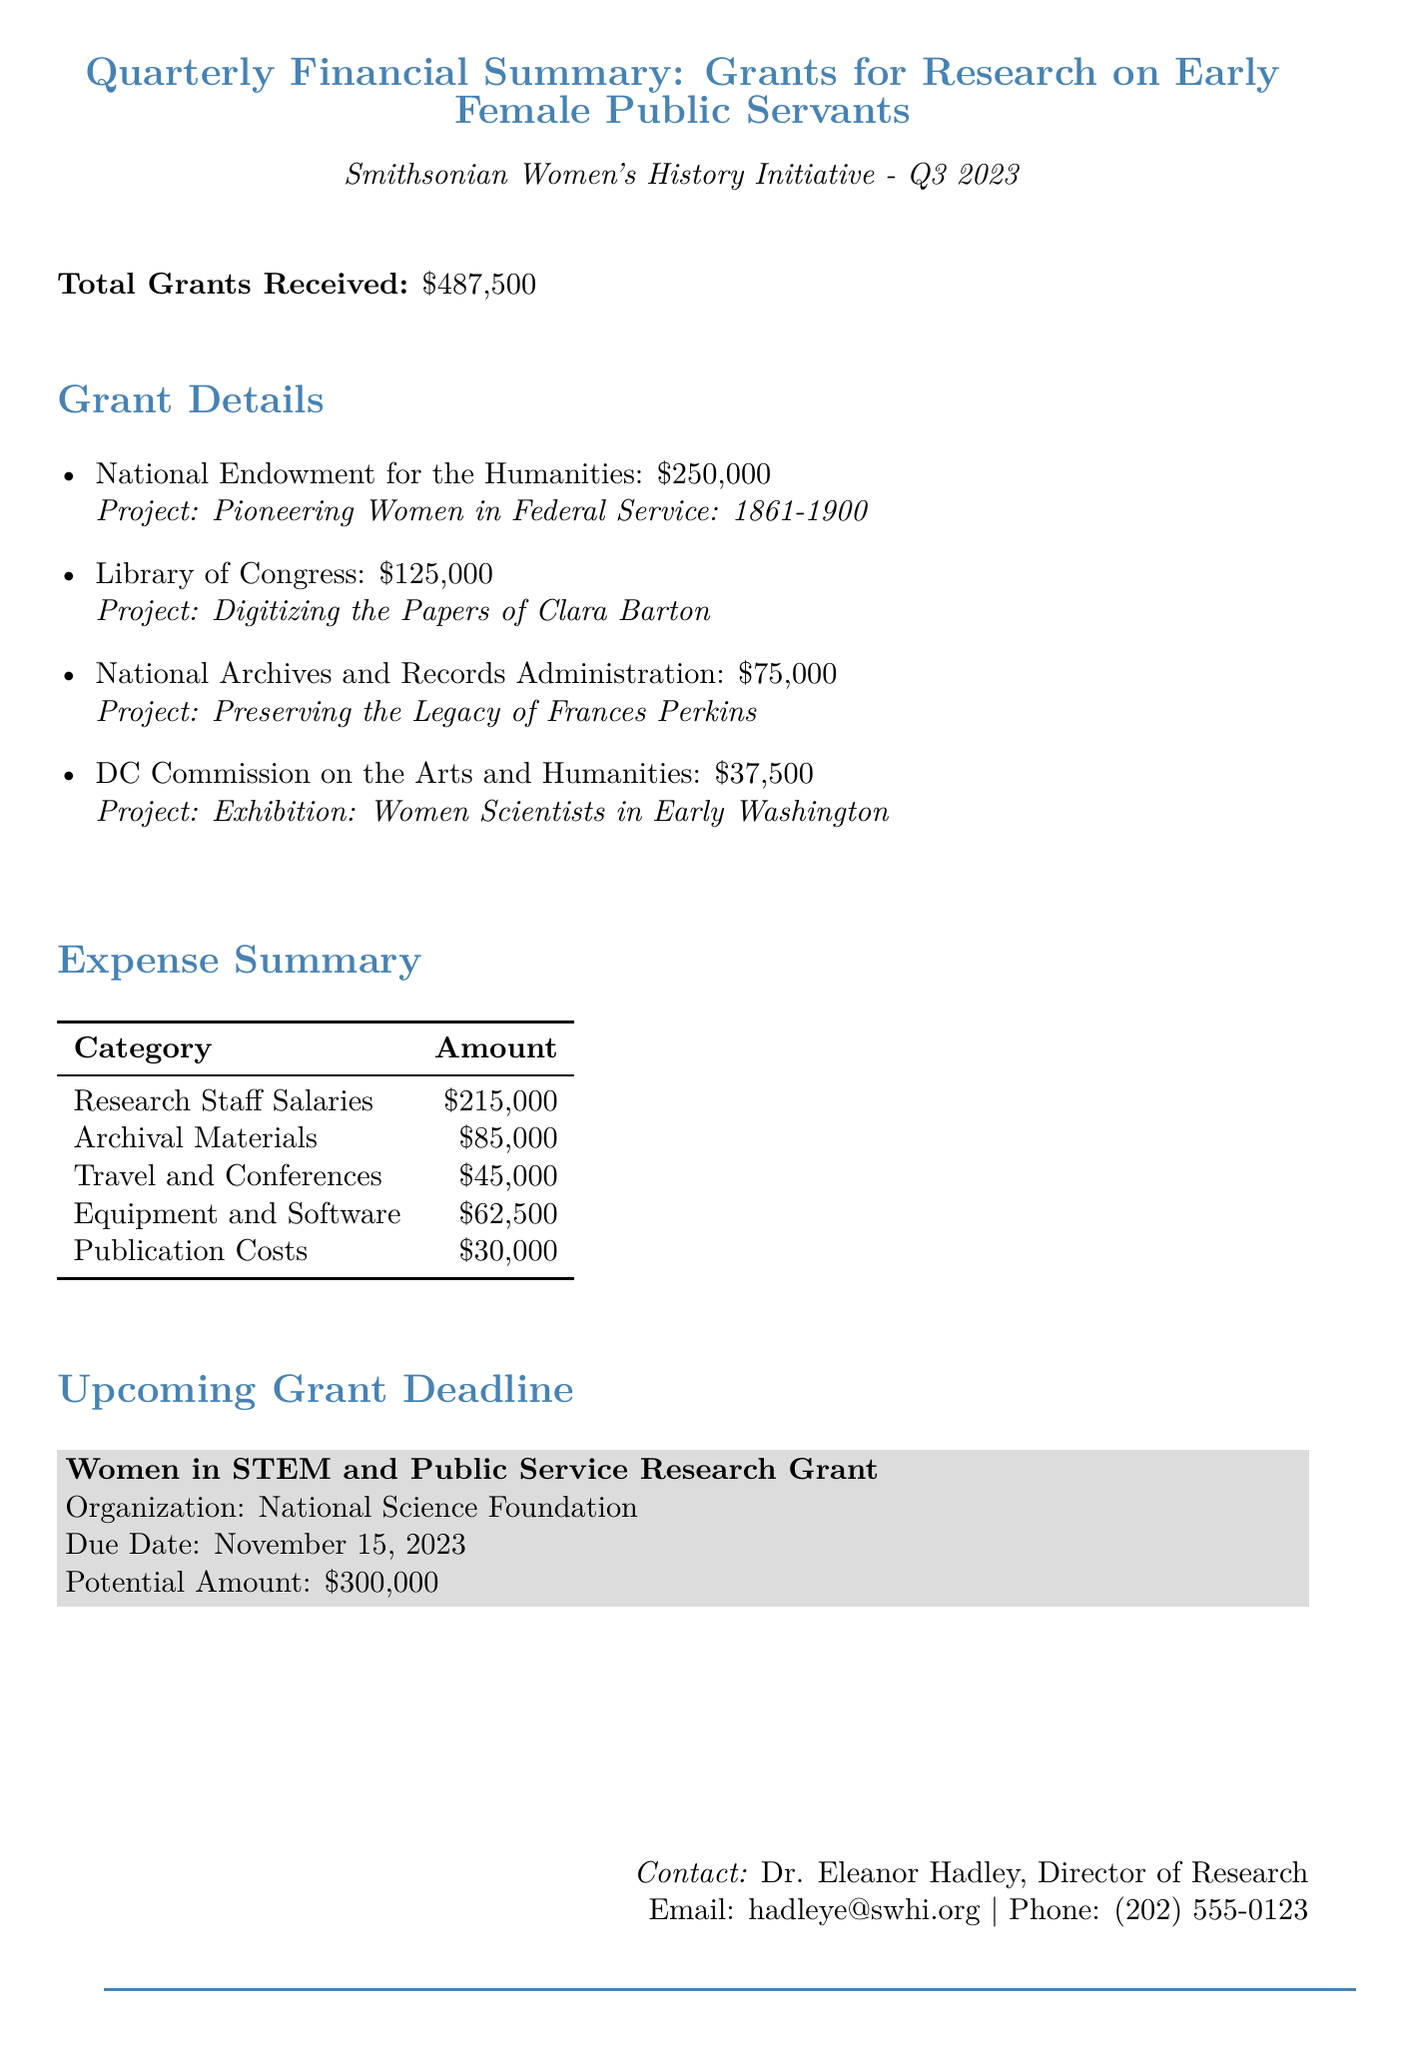What is the total amount of grants received? The total amount of grants received is directly stated in the financial summary section of the document.
Answer: $487,500 Who is the contact person for the report? The contact person is mentioned at the end of the document, including their title and contact details.
Answer: Dr. Eleanor Hadley What is the grant amount from the Library of Congress? The grant details section specifies the amount received from the Library of Congress for its respective project.
Answer: $125,000 What is the project name for the grant provided by the National Archives and Records Administration? The project name is included in the grant details section associated with that specific grantor.
Answer: Preserving the Legacy of Frances Perkins How much is allocated for research staff salaries? The expense summary provides a specific amount for research staff salaries, indicating a notable portion of the budget.
Answer: $215,000 Which organization is providing a potential upcoming grant? The document outlines any upcoming deadlines for grants, including the name of the organization related to the opportunity.
Answer: National Science Foundation What is the due date for the upcoming grant? The due date is clearly stated in the section regarding upcoming grants.
Answer: November 15, 2023 What is the total amount requested for the upcoming grant? The potential amount for the upcoming grant is explicitly detailed in its description within the document.
Answer: $300,000 What is the title of the project funded by the National Endowment for the Humanities? The title of the project is stated alongside the grant amount in the grant details section.
Answer: Pioneering Women in Federal Service: 1861-1900 